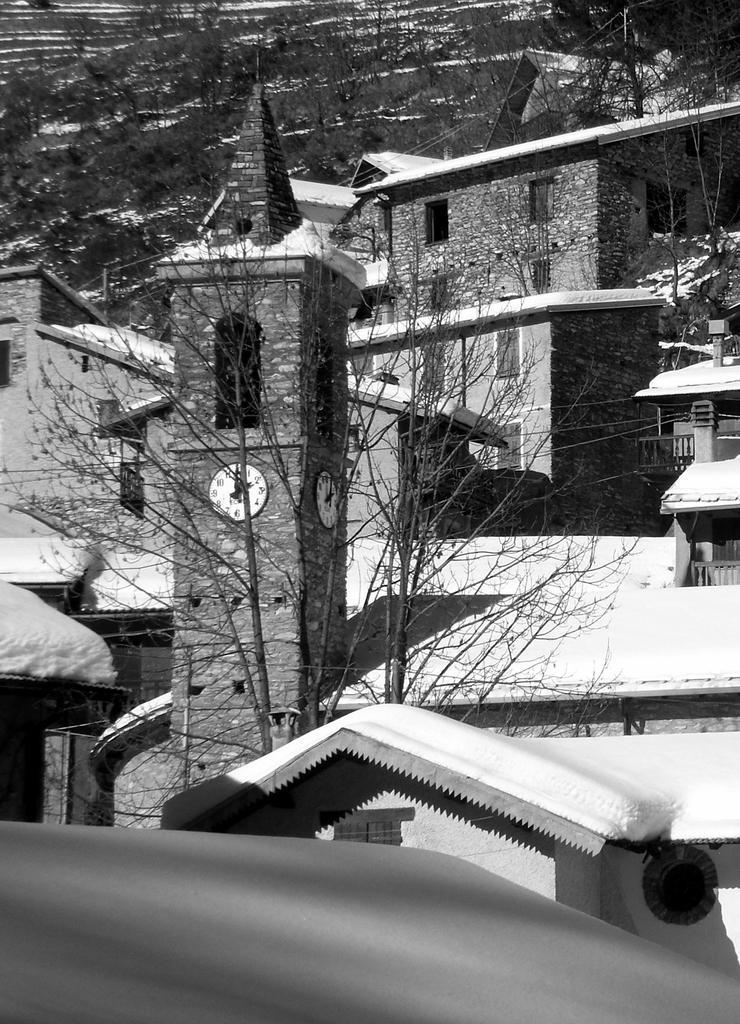Describe this image in one or two sentences. In this picture I can see buildings, trees and wires. This picture is black and white in color. 